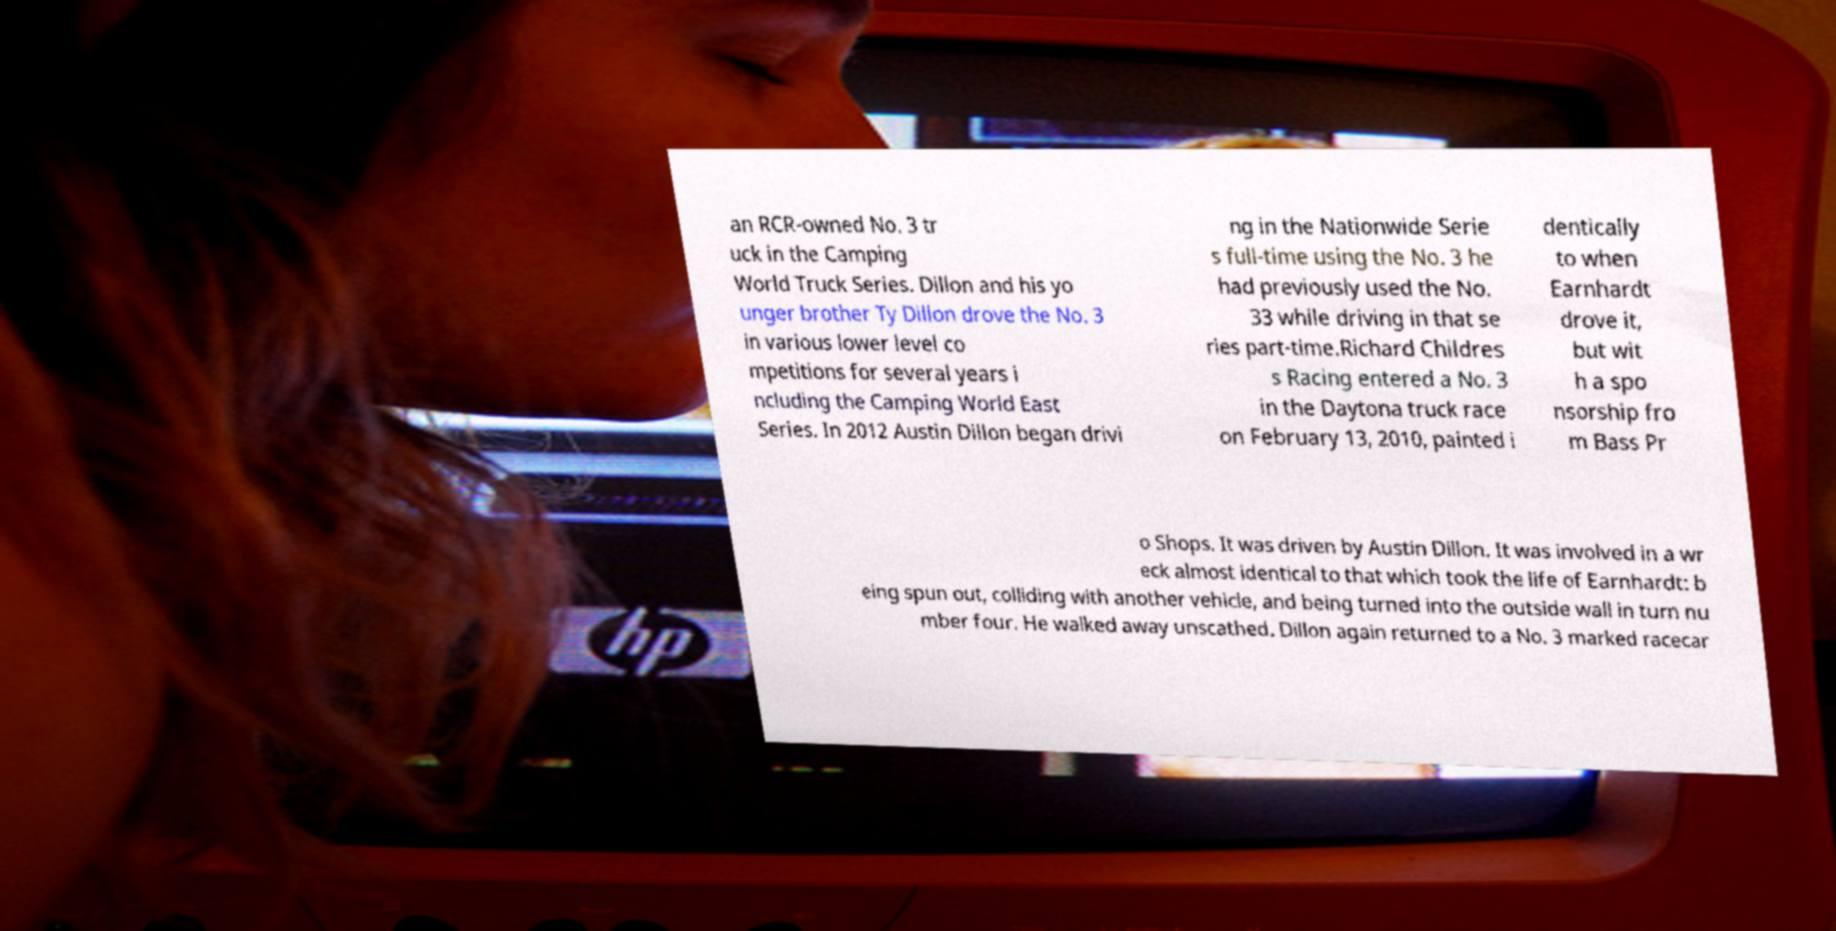What messages or text are displayed in this image? I need them in a readable, typed format. an RCR-owned No. 3 tr uck in the Camping World Truck Series. Dillon and his yo unger brother Ty Dillon drove the No. 3 in various lower level co mpetitions for several years i ncluding the Camping World East Series. In 2012 Austin Dillon began drivi ng in the Nationwide Serie s full-time using the No. 3 he had previously used the No. 33 while driving in that se ries part-time.Richard Childres s Racing entered a No. 3 in the Daytona truck race on February 13, 2010, painted i dentically to when Earnhardt drove it, but wit h a spo nsorship fro m Bass Pr o Shops. It was driven by Austin Dillon. It was involved in a wr eck almost identical to that which took the life of Earnhardt: b eing spun out, colliding with another vehicle, and being turned into the outside wall in turn nu mber four. He walked away unscathed. Dillon again returned to a No. 3 marked racecar 